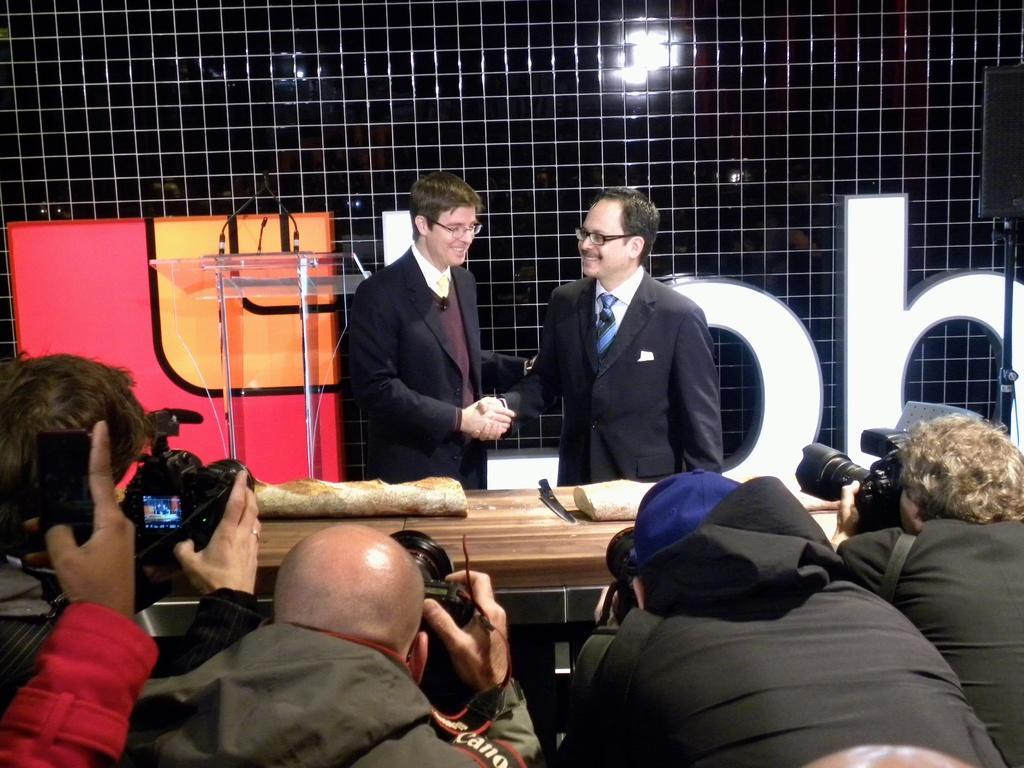Describe this image in one or two sentences. In this image we can see few people, some of them are holding cameras and clicking pictures, there is a table with few object, there is a podium with mics behind the person and a wall with text in the background. 